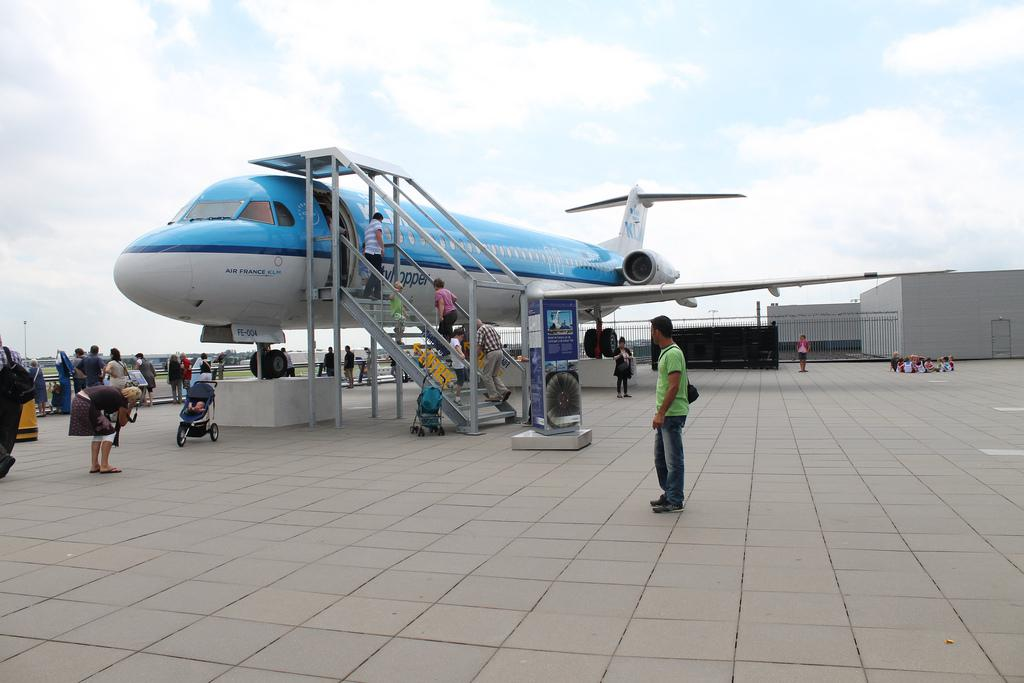Question: when is the photo taken?
Choices:
A. Day.
B. The night of the Academy Awards.
C. Just as she sneezed.
D. At the break of dawn.
Answer with the letter. Answer: A Question: why is it bright out?
Choices:
A. The lightening made it bright.
B. There is a bonfire that is seven stories high.
C. Because of a flurry of solar flares 8 minutes ago.
D. Because it is during the day.
Answer with the letter. Answer: D Question: who is flying the plane?
Choices:
A. The drone operator on the ground.
B. The Air Force pilot.
C. Two experienced pilots.
D. No one.
Answer with the letter. Answer: D Question: where is the stroller?
Choices:
A. Behind the plane.
B. To the left of the plane.
C. To the right of the plane.
D. In front of the plane.
Answer with the letter. Answer: D Question: what are the plane's wheels resting on?
Choices:
A. Grass.
B. Cement.
C. Gravel.
D. Large blocks.
Answer with the letter. Answer: D Question: what is in the back?
Choices:
A. Plane's propeller.
B. Plane's cockpit.
C. Plane's engines.
D. Plane's front wheels.
Answer with the letter. Answer: C Question: who is bent over to the left?
Choices:
A. A large man.
B. A little girl.
C. Woman.
D. A tall boy.
Answer with the letter. Answer: C Question: what is in front of plane's front wheel?
Choices:
A. A dog.
B. A serving cart.
C. Unattended stroller.
D. A blue ball.
Answer with the letter. Answer: C Question: where do you see a woman in a pink sweater?
Choices:
A. Sitting in chair.
B. All over.
C. Walking up the stairs to the plane.
D. In bed.
Answer with the letter. Answer: C Question: what door on the plane is open?
Choices:
A. Back.
B. The passenger door.
C. Front.
D. Side.
Answer with the letter. Answer: B Question: where is the information kiosk?
Choices:
A. At the front desk of the hotel.
B. Near the entrance to the museum.
C. Next to the plane.
D. In the center of the mall.
Answer with the letter. Answer: C 